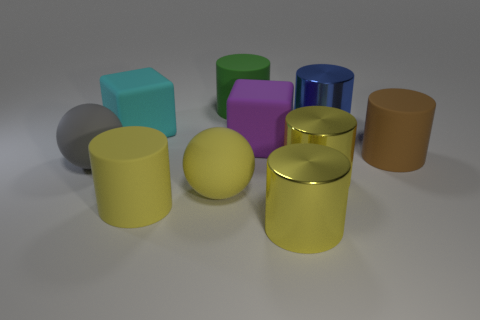How many other objects are the same shape as the purple matte object?
Your answer should be very brief. 1. What material is the big cylinder that is to the left of the purple block and behind the large brown cylinder?
Make the answer very short. Rubber. The brown thing is what size?
Provide a short and direct response. Large. How many blue shiny things are in front of the brown object in front of the large block right of the cyan rubber cube?
Keep it short and to the point. 0. There is a matte thing that is on the left side of the big rubber cube that is left of the green matte cylinder; what shape is it?
Your answer should be compact. Sphere. There is a blue shiny thing that is the same shape as the big brown thing; what is its size?
Your answer should be very brief. Large. Is there anything else that is the same size as the green rubber cylinder?
Provide a short and direct response. Yes. What color is the matte thing that is to the right of the big purple block?
Your answer should be compact. Brown. What is the material of the yellow cylinder on the left side of the big cube in front of the cube behind the big purple block?
Your answer should be compact. Rubber. How big is the shiny thing in front of the big matte sphere in front of the gray matte ball?
Your answer should be very brief. Large. 